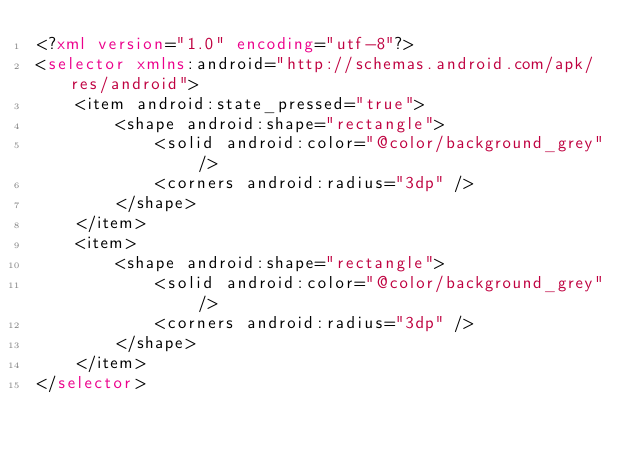<code> <loc_0><loc_0><loc_500><loc_500><_XML_><?xml version="1.0" encoding="utf-8"?>
<selector xmlns:android="http://schemas.android.com/apk/res/android">
    <item android:state_pressed="true">
        <shape android:shape="rectangle">
            <solid android:color="@color/background_grey" />
            <corners android:radius="3dp" />
        </shape>
    </item>
    <item>
        <shape android:shape="rectangle">
            <solid android:color="@color/background_grey" />
            <corners android:radius="3dp" />
        </shape>
    </item>
</selector></code> 